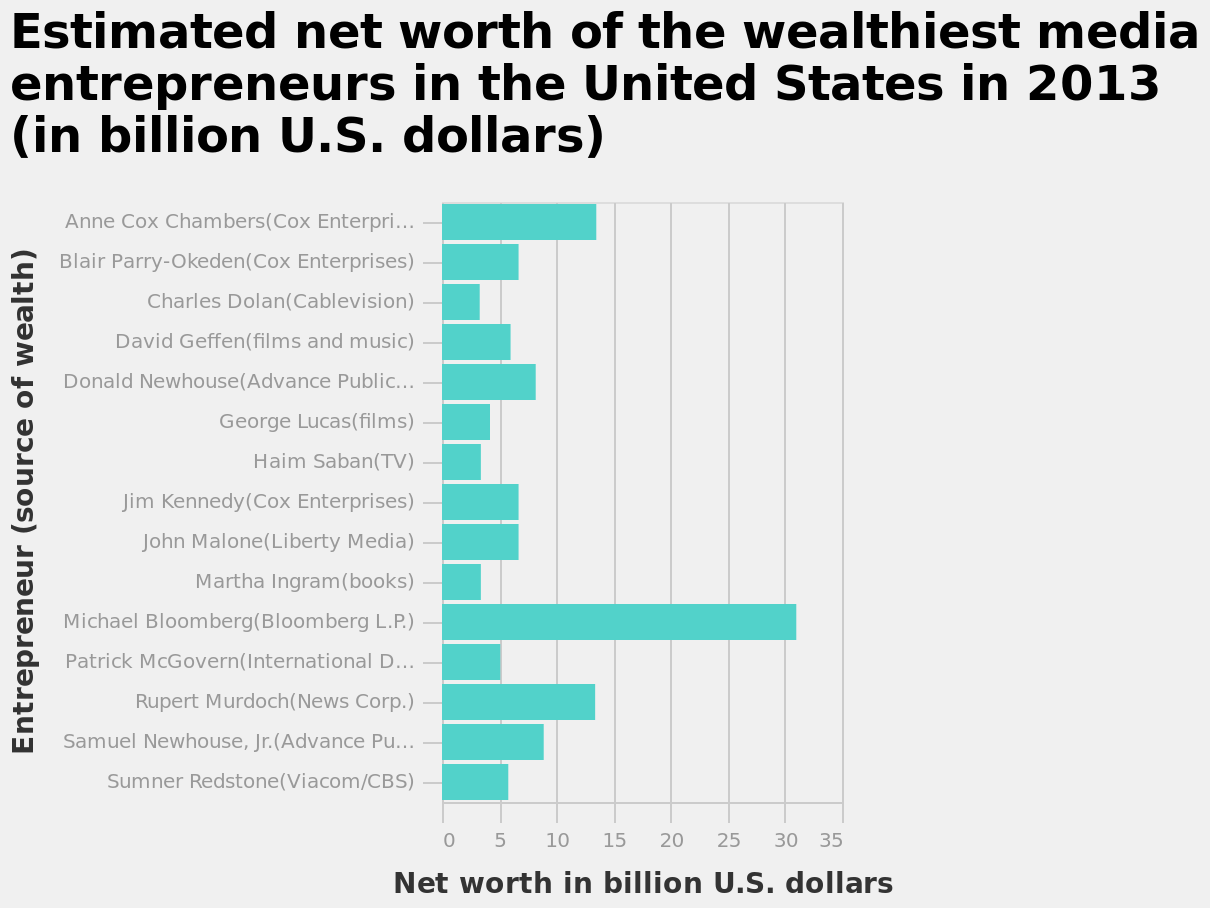<image>
Who is the wealthiest entrepreneur in the United States in terms of their net worth?  Michael Bloomberg. What is the title of the bar diagram?  The title of the bar diagram is "Estimated net worth of the wealthiest media entrepreneurs in the United States in 2013 (in billion U.S. dollars)." please describe the details of the chart This is a bar diagram titled Estimated net worth of the wealthiest media entrepreneurs in the United States in 2013 (in billion U.S. dollars). On the x-axis, Net worth in billion U.S. dollars is drawn. Along the y-axis, Entrepreneur (source of wealth) is defined. 